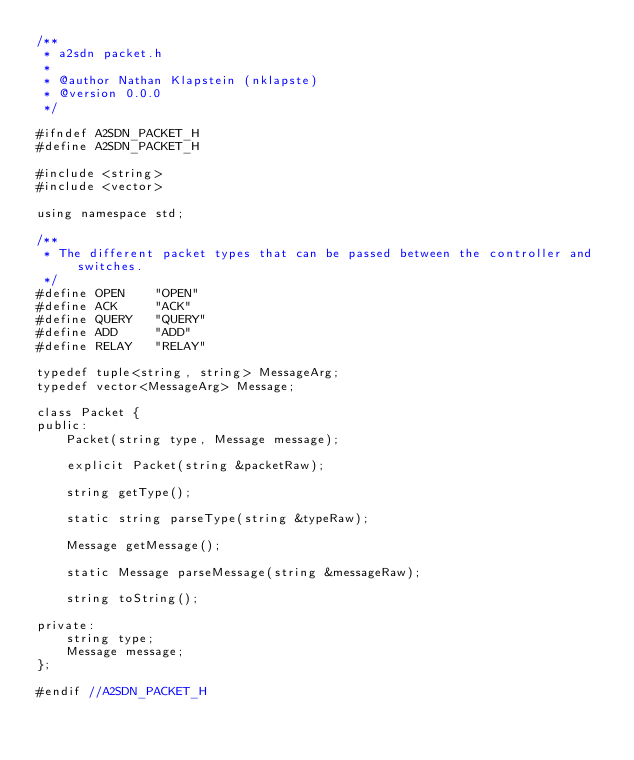Convert code to text. <code><loc_0><loc_0><loc_500><loc_500><_C_>/**
 * a2sdn packet.h
 *
 * @author Nathan Klapstein (nklapste)
 * @version 0.0.0
 */

#ifndef A2SDN_PACKET_H
#define A2SDN_PACKET_H

#include <string>
#include <vector>

using namespace std;

/**
 * The different packet types that can be passed between the controller and switches.
 */
#define OPEN    "OPEN"
#define ACK     "ACK"
#define QUERY   "QUERY"
#define ADD     "ADD"
#define RELAY   "RELAY"

typedef tuple<string, string> MessageArg;
typedef vector<MessageArg> Message;

class Packet {
public:
    Packet(string type, Message message);

    explicit Packet(string &packetRaw);

    string getType();

    static string parseType(string &typeRaw);

    Message getMessage();

    static Message parseMessage(string &messageRaw);

    string toString();

private:
    string type;
    Message message;
};

#endif //A2SDN_PACKET_H
</code> 